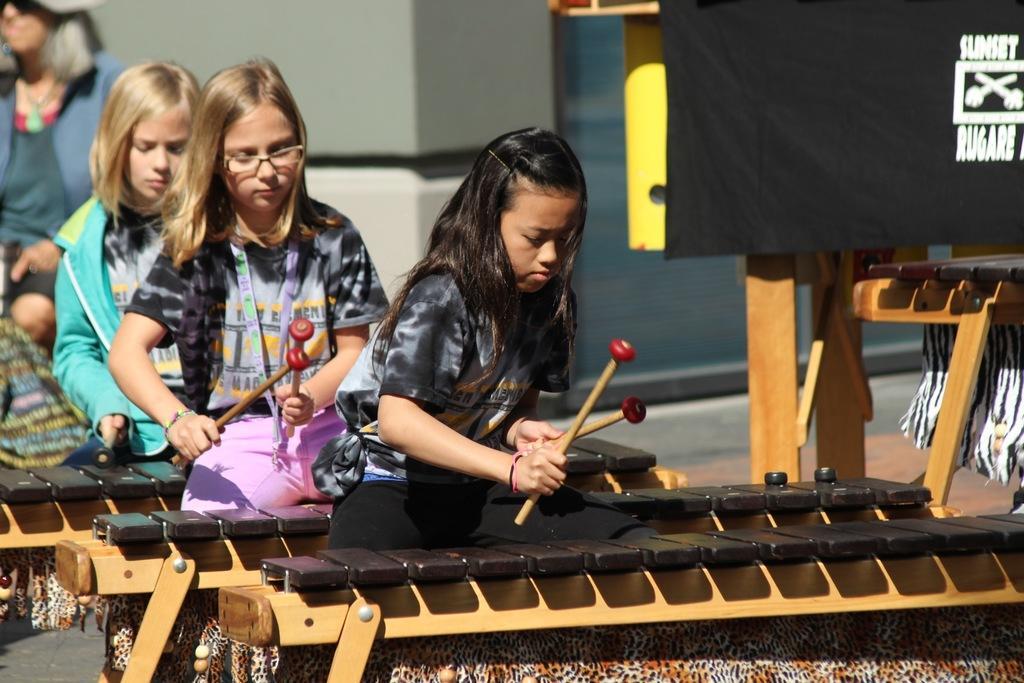Describe this image in one or two sentences. In the image we can see there are children sitting, they are wearing clothes and holding drum sticks in their hands. Here we can see the musical instruments, the banner and the background is slightly blurred. 